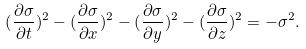<formula> <loc_0><loc_0><loc_500><loc_500>( \frac { \partial \sigma } { \partial t } ) ^ { 2 } - ( \frac { \partial \sigma } { \partial x } ) ^ { 2 } - ( \frac { \partial \sigma } { \partial y } ) ^ { 2 } - ( \frac { \partial \sigma } { \partial z } ) ^ { 2 } = - \sigma ^ { 2 } .</formula> 